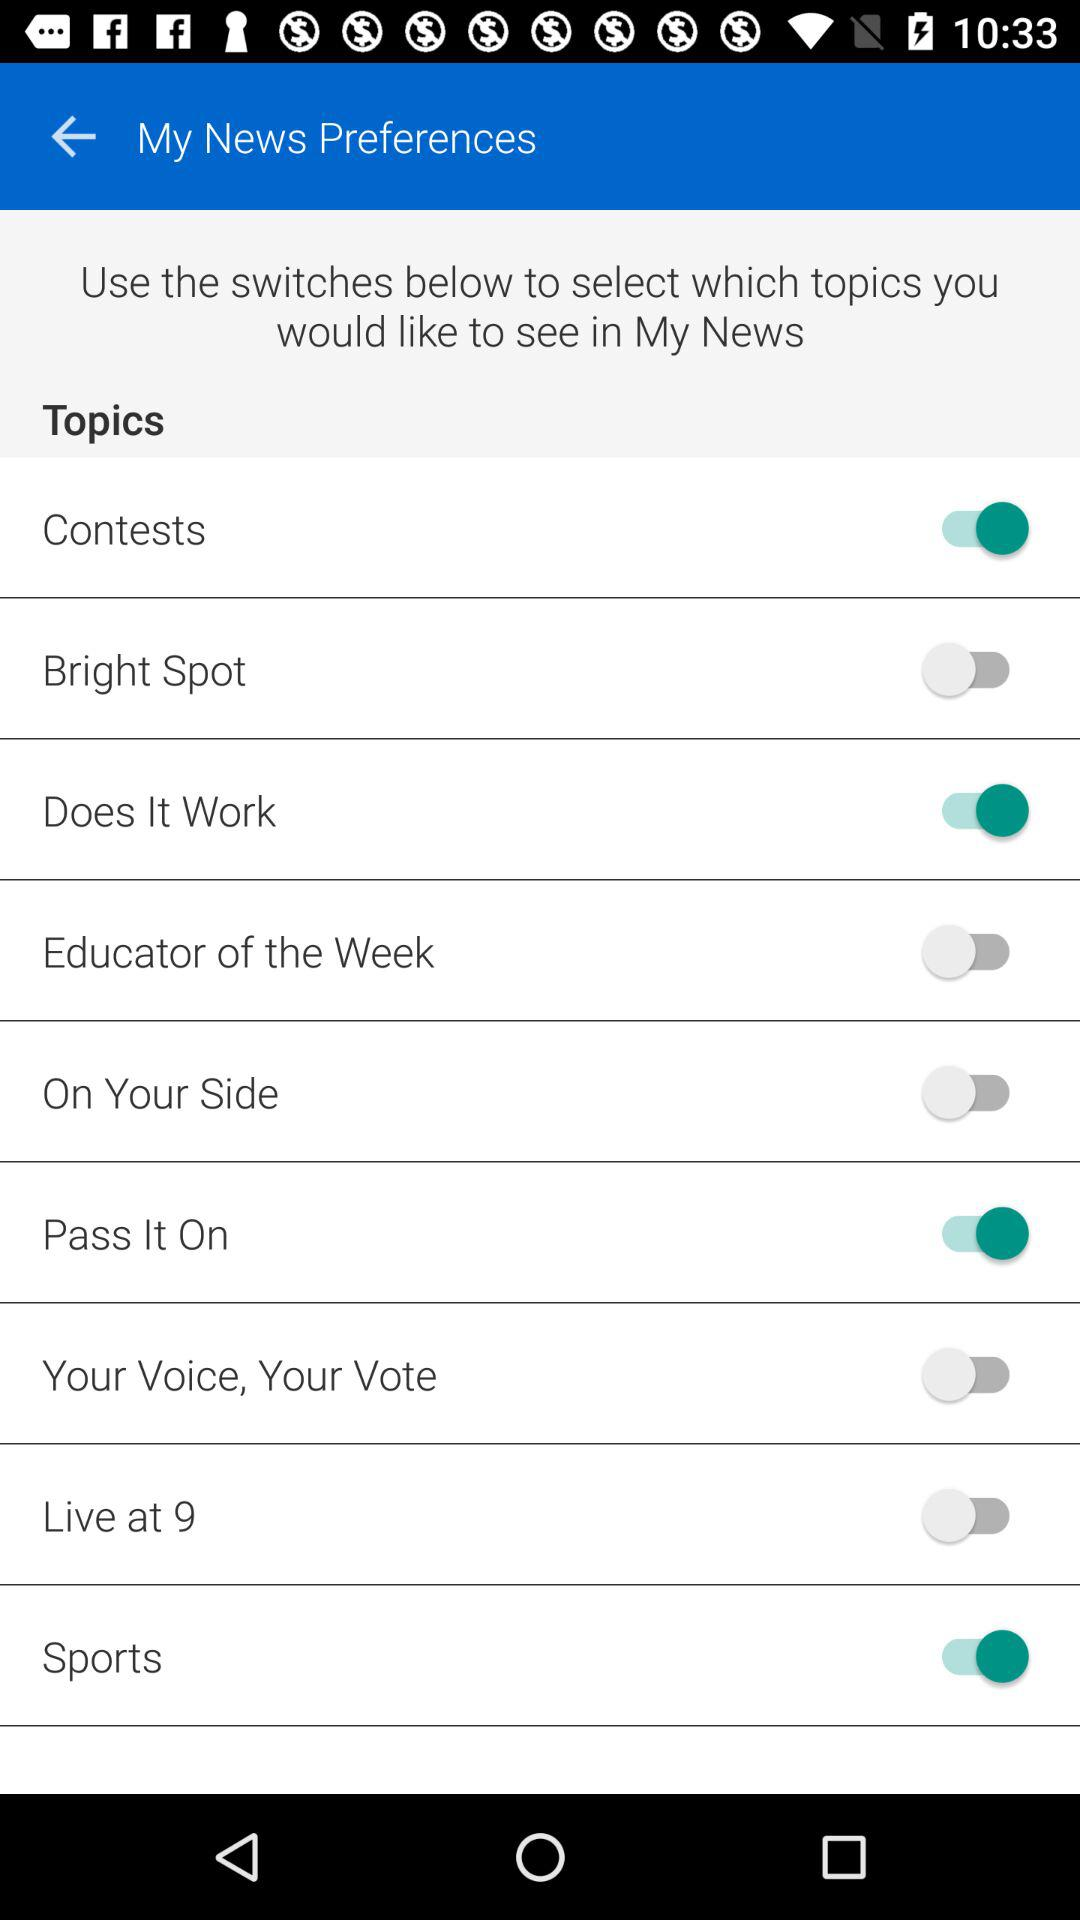What is the status of the "Sports"? The status is "on". 